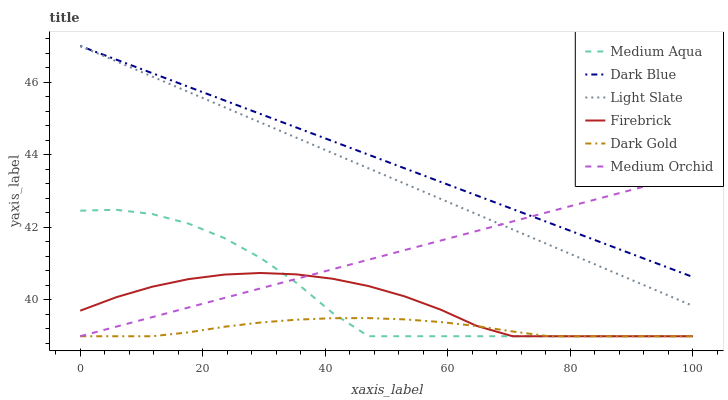Does Dark Gold have the minimum area under the curve?
Answer yes or no. Yes. Does Dark Blue have the maximum area under the curve?
Answer yes or no. Yes. Does Light Slate have the minimum area under the curve?
Answer yes or no. No. Does Light Slate have the maximum area under the curve?
Answer yes or no. No. Is Dark Blue the smoothest?
Answer yes or no. Yes. Is Medium Aqua the roughest?
Answer yes or no. Yes. Is Light Slate the smoothest?
Answer yes or no. No. Is Light Slate the roughest?
Answer yes or no. No. Does Dark Gold have the lowest value?
Answer yes or no. Yes. Does Light Slate have the lowest value?
Answer yes or no. No. Does Dark Blue have the highest value?
Answer yes or no. Yes. Does Firebrick have the highest value?
Answer yes or no. No. Is Dark Gold less than Light Slate?
Answer yes or no. Yes. Is Light Slate greater than Medium Aqua?
Answer yes or no. Yes. Does Medium Orchid intersect Firebrick?
Answer yes or no. Yes. Is Medium Orchid less than Firebrick?
Answer yes or no. No. Is Medium Orchid greater than Firebrick?
Answer yes or no. No. Does Dark Gold intersect Light Slate?
Answer yes or no. No. 